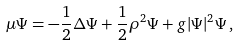Convert formula to latex. <formula><loc_0><loc_0><loc_500><loc_500>\mu \Psi = - \frac { 1 } { 2 } \Delta \Psi + \frac { 1 } { 2 } \rho ^ { 2 } \Psi + g | \Psi | ^ { 2 } \Psi \, ,</formula> 